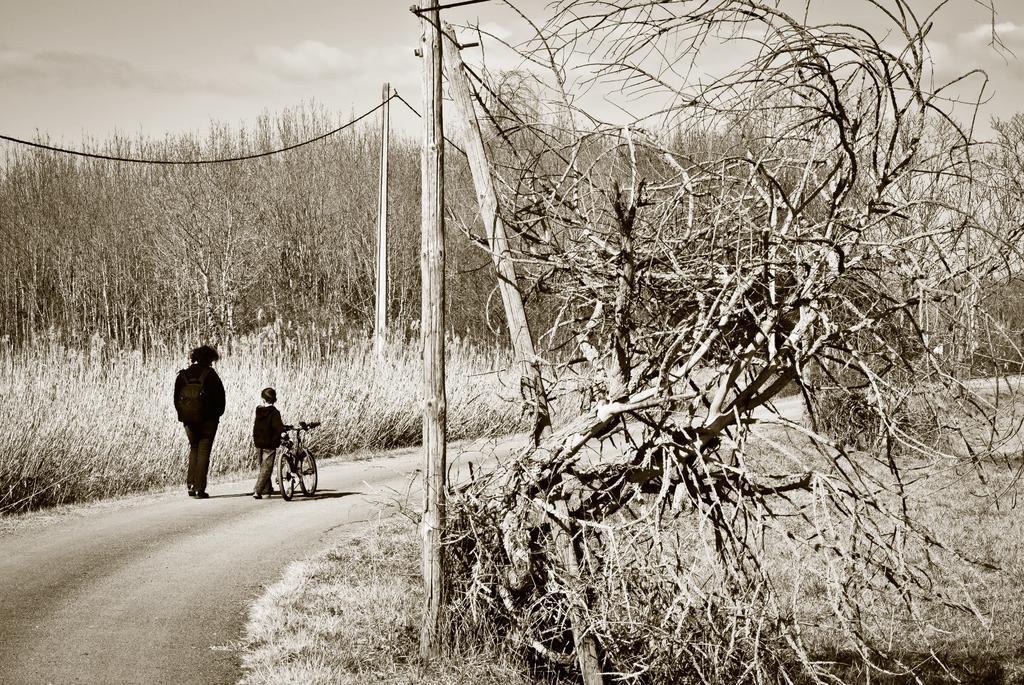Could you give a brief overview of what you see in this image? In the picture we can see a pathway on it, we can see a man and a boy are walking, boy is holding a bicycle and on the both the sides of the path we can see grass plants and poles with wires and in the background we can see trees and sky with clouds. 